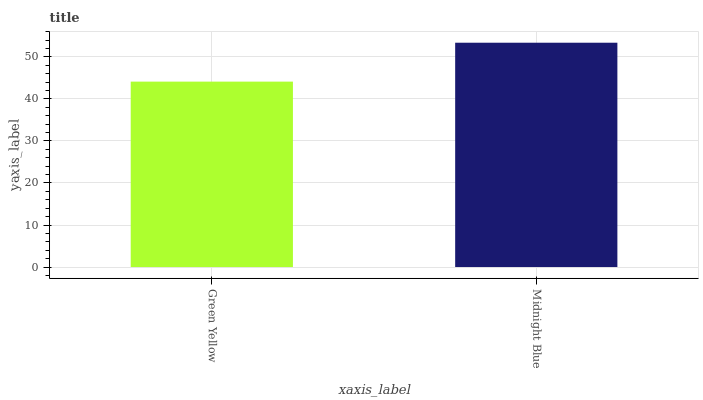Is Green Yellow the minimum?
Answer yes or no. Yes. Is Midnight Blue the maximum?
Answer yes or no. Yes. Is Midnight Blue the minimum?
Answer yes or no. No. Is Midnight Blue greater than Green Yellow?
Answer yes or no. Yes. Is Green Yellow less than Midnight Blue?
Answer yes or no. Yes. Is Green Yellow greater than Midnight Blue?
Answer yes or no. No. Is Midnight Blue less than Green Yellow?
Answer yes or no. No. Is Midnight Blue the high median?
Answer yes or no. Yes. Is Green Yellow the low median?
Answer yes or no. Yes. Is Green Yellow the high median?
Answer yes or no. No. Is Midnight Blue the low median?
Answer yes or no. No. 